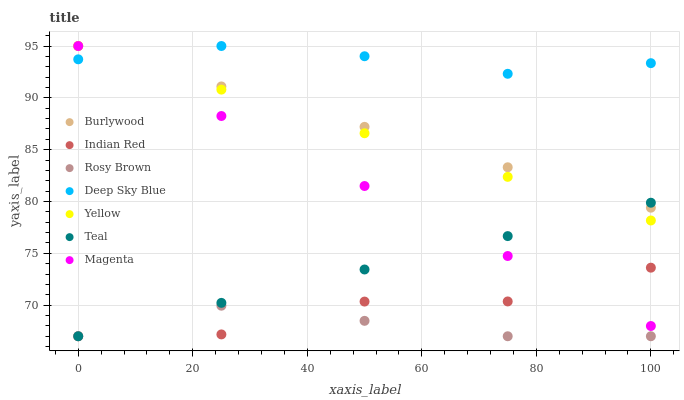Does Rosy Brown have the minimum area under the curve?
Answer yes or no. Yes. Does Deep Sky Blue have the maximum area under the curve?
Answer yes or no. Yes. Does Burlywood have the minimum area under the curve?
Answer yes or no. No. Does Burlywood have the maximum area under the curve?
Answer yes or no. No. Is Burlywood the smoothest?
Answer yes or no. Yes. Is Indian Red the roughest?
Answer yes or no. Yes. Is Rosy Brown the smoothest?
Answer yes or no. No. Is Rosy Brown the roughest?
Answer yes or no. No. Does Rosy Brown have the lowest value?
Answer yes or no. Yes. Does Burlywood have the lowest value?
Answer yes or no. No. Does Magenta have the highest value?
Answer yes or no. Yes. Does Rosy Brown have the highest value?
Answer yes or no. No. Is Rosy Brown less than Yellow?
Answer yes or no. Yes. Is Burlywood greater than Rosy Brown?
Answer yes or no. Yes. Does Magenta intersect Teal?
Answer yes or no. Yes. Is Magenta less than Teal?
Answer yes or no. No. Is Magenta greater than Teal?
Answer yes or no. No. Does Rosy Brown intersect Yellow?
Answer yes or no. No. 